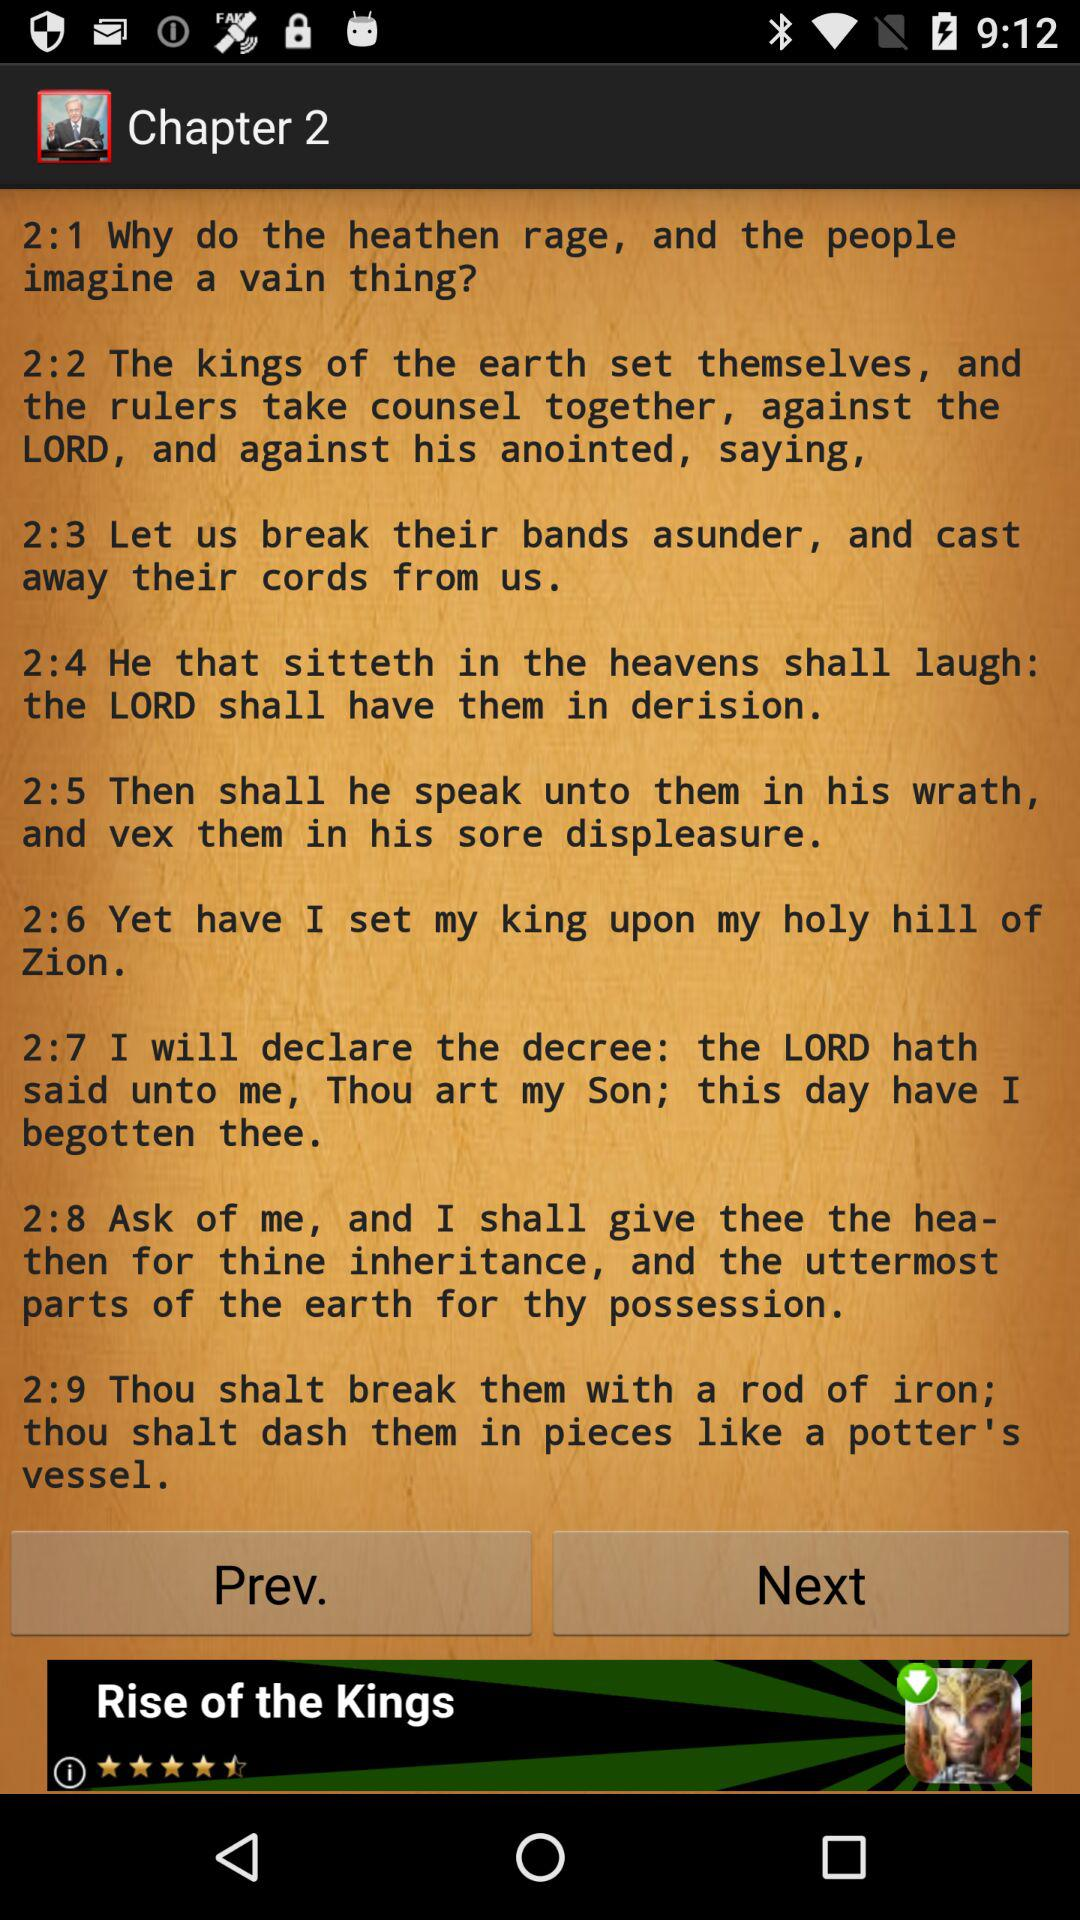How many verses are in this chapter?
Answer the question using a single word or phrase. 9 